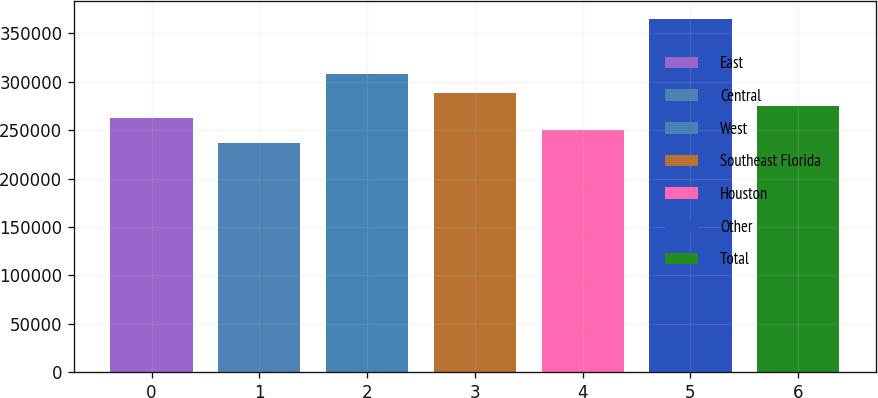Convert chart. <chart><loc_0><loc_0><loc_500><loc_500><bar_chart><fcel>East<fcel>Central<fcel>West<fcel>Southeast Florida<fcel>Houston<fcel>Other<fcel>Total<nl><fcel>262600<fcel>237000<fcel>308000<fcel>288200<fcel>249800<fcel>365000<fcel>275400<nl></chart> 